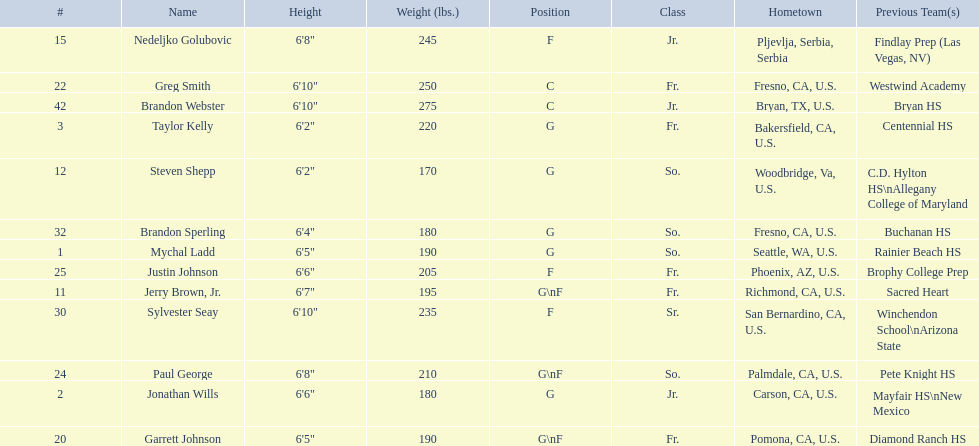Which positions are so.? G, G, G\nF, G. Which weights are g 190, 170, 180. What height is under 6 3' 6'2". What is the name Steven Shepp. 